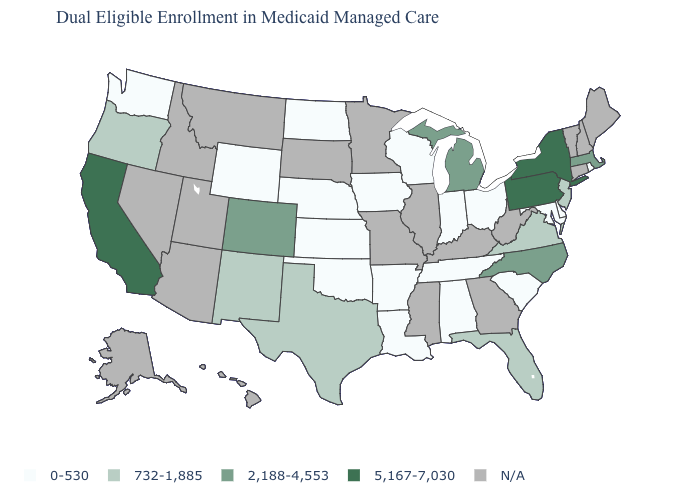Which states have the lowest value in the USA?
Concise answer only. Alabama, Arkansas, Delaware, Indiana, Iowa, Kansas, Louisiana, Maryland, Nebraska, North Dakota, Ohio, Oklahoma, Rhode Island, South Carolina, Tennessee, Washington, Wisconsin, Wyoming. Name the states that have a value in the range 732-1,885?
Keep it brief. Florida, New Jersey, New Mexico, Oregon, Texas, Virginia. What is the value of South Dakota?
Short answer required. N/A. What is the value of South Dakota?
Concise answer only. N/A. Among the states that border Minnesota , which have the lowest value?
Short answer required. Iowa, North Dakota, Wisconsin. What is the value of Florida?
Answer briefly. 732-1,885. How many symbols are there in the legend?
Write a very short answer. 5. What is the highest value in the USA?
Keep it brief. 5,167-7,030. Does New Jersey have the lowest value in the USA?
Answer briefly. No. What is the highest value in the MidWest ?
Give a very brief answer. 2,188-4,553. Name the states that have a value in the range N/A?
Concise answer only. Alaska, Arizona, Connecticut, Georgia, Hawaii, Idaho, Illinois, Kentucky, Maine, Minnesota, Mississippi, Missouri, Montana, Nevada, New Hampshire, South Dakota, Utah, Vermont, West Virginia. Name the states that have a value in the range 0-530?
Write a very short answer. Alabama, Arkansas, Delaware, Indiana, Iowa, Kansas, Louisiana, Maryland, Nebraska, North Dakota, Ohio, Oklahoma, Rhode Island, South Carolina, Tennessee, Washington, Wisconsin, Wyoming. What is the value of Iowa?
Answer briefly. 0-530. What is the lowest value in the South?
Keep it brief. 0-530. 